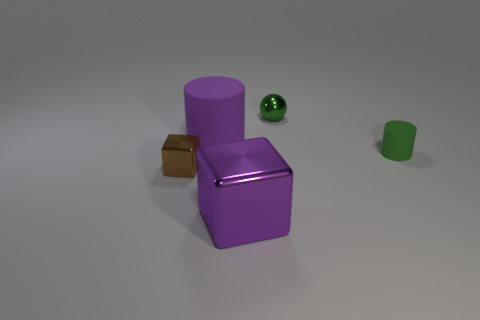How many large things are either purple things or green balls? In the image, there are two large items—a purple cylinder and a purple cube. Although there is a green ball, it is smaller in size and thus not counted among the 'large things.' Therefore, there are two large things that are purple. 